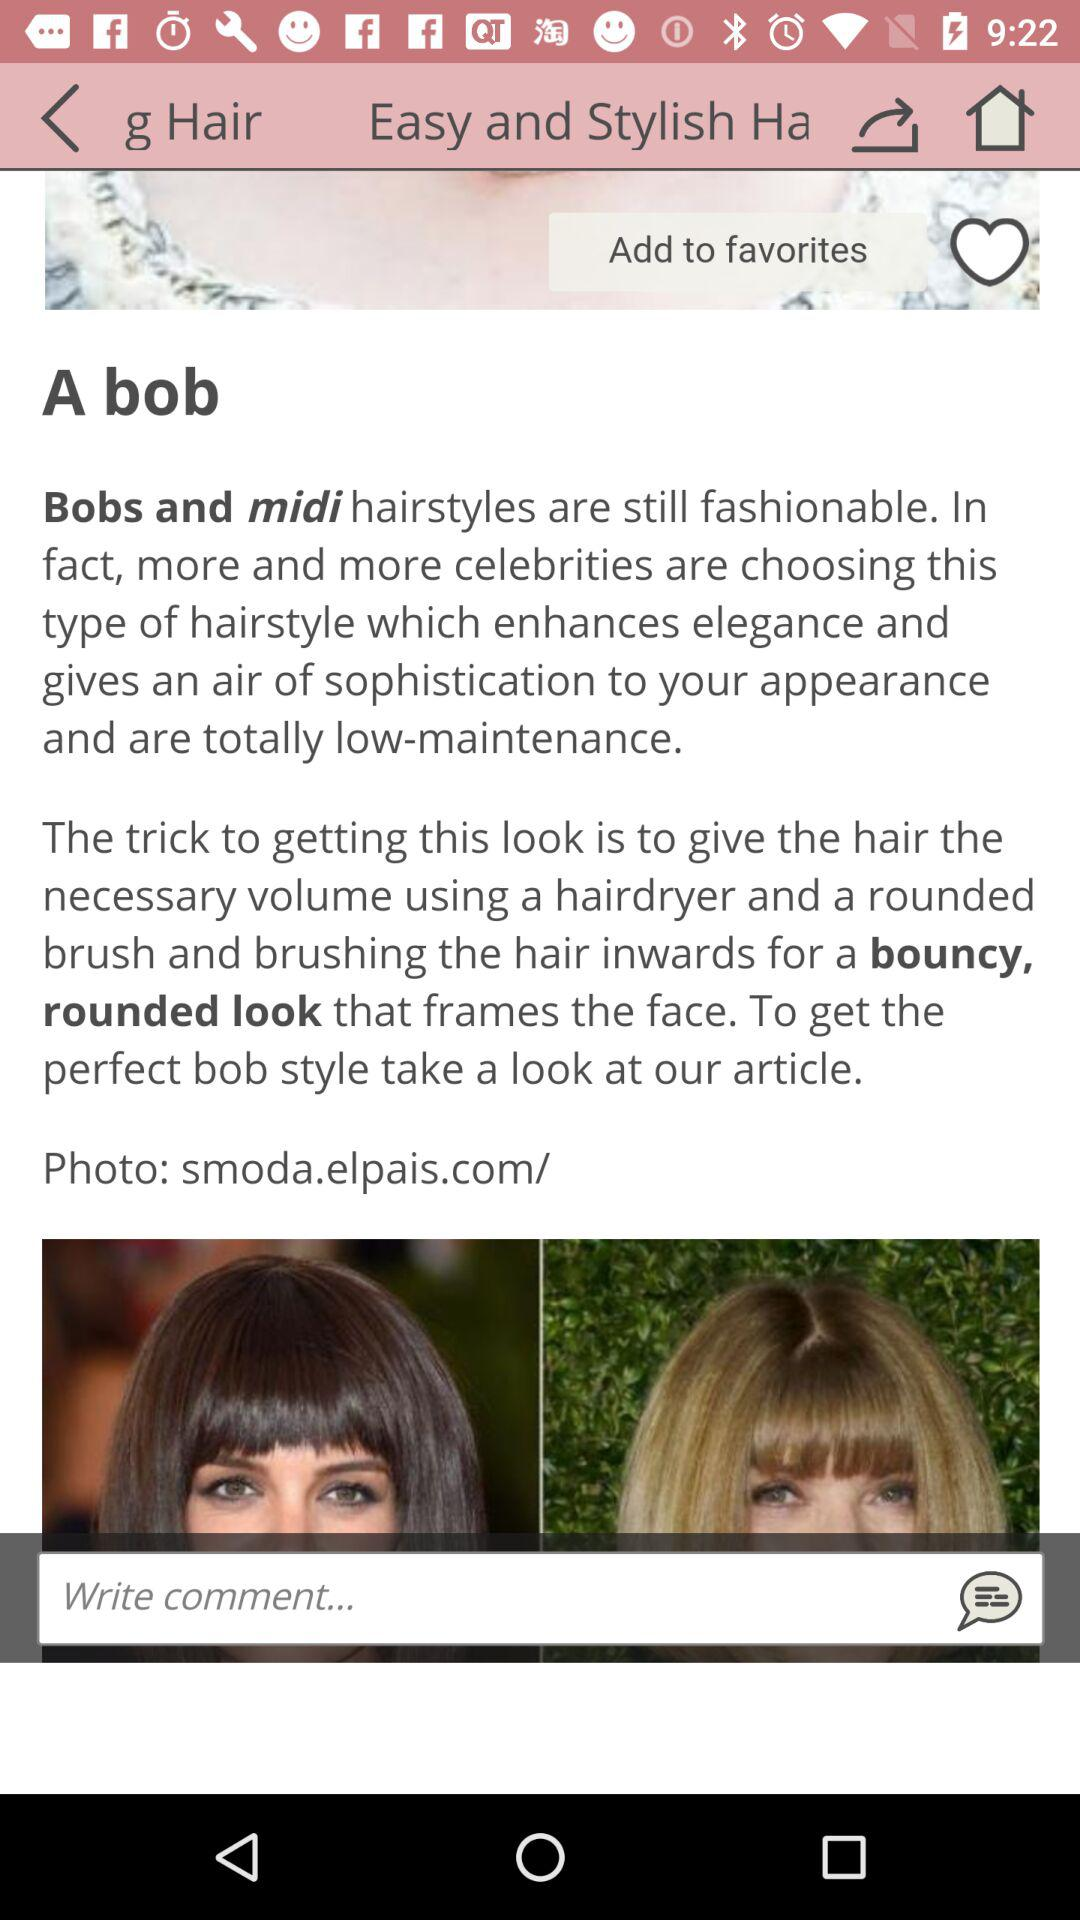What is the name of the application? The name of the application is "g Hair". 